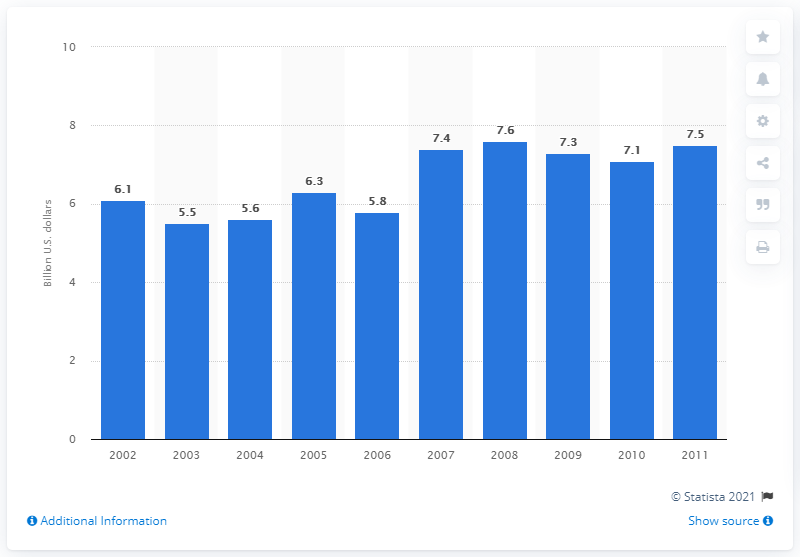Identify some key points in this picture. The value of U.S. product shipments of creams, lotions, and oils in 2009 was 7.3 billion dollars. 